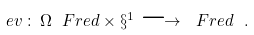<formula> <loc_0><loc_0><loc_500><loc_500>\ e v \, \colon \, { \Omega \ F r e d } \times \S ^ { 1 } \longrightarrow \ F r e d \ .</formula> 